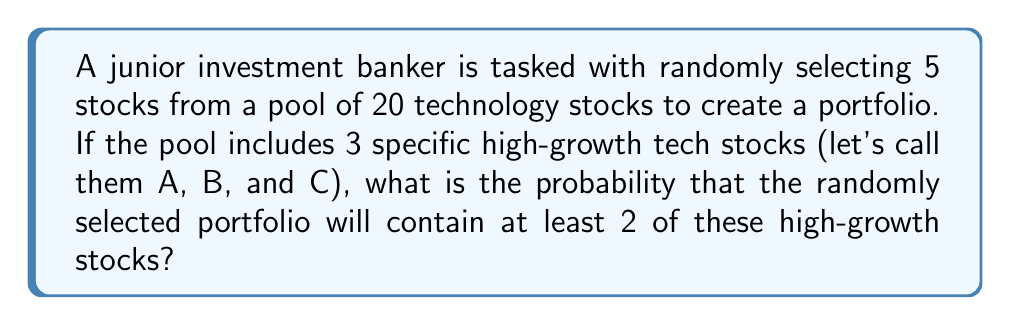Solve this math problem. Let's approach this step-by-step using the concept of combinations:

1) First, we need to calculate the total number of ways to select 5 stocks from 20:
   $${20 \choose 5} = \frac{20!}{5!(20-5)!} = 15,504$$

2) Now, we need to calculate the number of favorable outcomes. We can have:
   a) Exactly 2 of the high-growth stocks
   b) All 3 of the high-growth stocks

3) For case a (2 high-growth stocks):
   - Choose 2 from the 3 high-growth stocks: ${3 \choose 2} = 3$
   - Choose 3 from the remaining 17 stocks: ${17 \choose 3} = 680$
   - Total combinations: $3 \times 680 = 2,040$

4) For case b (3 high-growth stocks):
   - Choose all 3 high-growth stocks: ${3 \choose 3} = 1$
   - Choose 2 from the remaining 17 stocks: ${17 \choose 2} = 136$
   - Total combinations: $1 \times 136 = 136$

5) Total favorable outcomes: $2,040 + 136 = 2,176$

6) Probability = (Favorable outcomes) / (Total outcomes)
   $$P = \frac{2,176}{15,504} = \frac{136}{969} \approx 0.1403$$
Answer: $\frac{136}{969} \approx 0.1403$ 